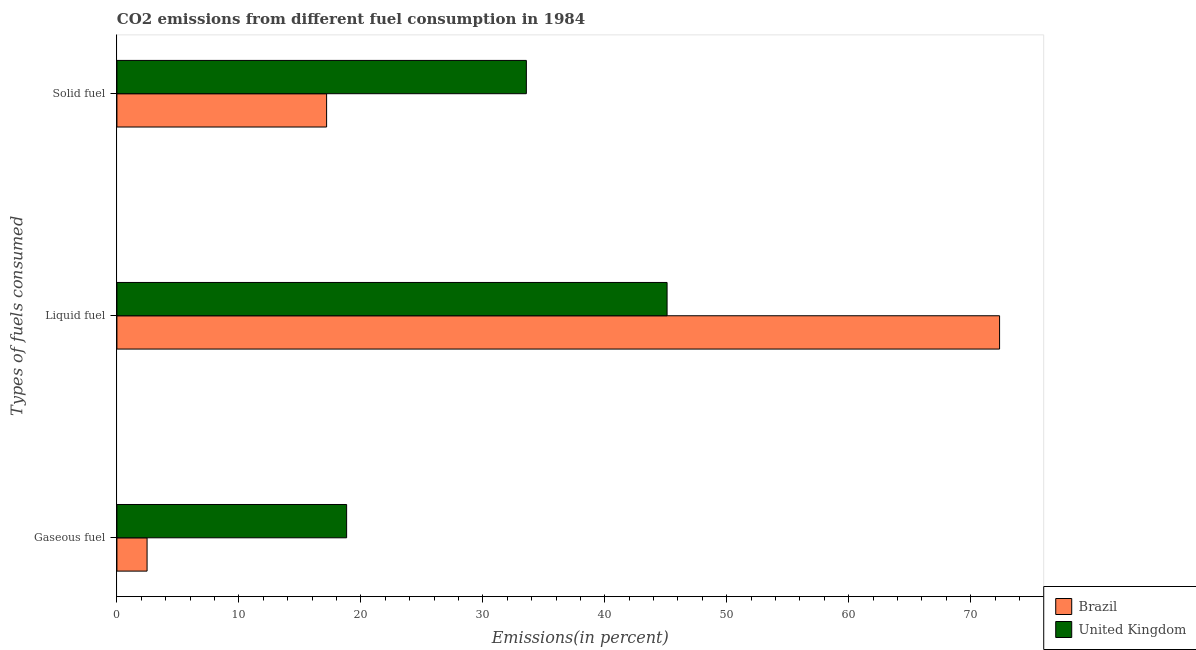How many different coloured bars are there?
Make the answer very short. 2. How many groups of bars are there?
Make the answer very short. 3. Are the number of bars per tick equal to the number of legend labels?
Offer a very short reply. Yes. How many bars are there on the 3rd tick from the top?
Your answer should be compact. 2. What is the label of the 1st group of bars from the top?
Provide a succinct answer. Solid fuel. What is the percentage of gaseous fuel emission in Brazil?
Make the answer very short. 2.47. Across all countries, what is the maximum percentage of liquid fuel emission?
Provide a succinct answer. 72.37. Across all countries, what is the minimum percentage of liquid fuel emission?
Keep it short and to the point. 45.11. What is the total percentage of gaseous fuel emission in the graph?
Your response must be concise. 21.31. What is the difference between the percentage of liquid fuel emission in Brazil and that in United Kingdom?
Make the answer very short. 27.26. What is the difference between the percentage of solid fuel emission in United Kingdom and the percentage of liquid fuel emission in Brazil?
Your answer should be very brief. -38.8. What is the average percentage of solid fuel emission per country?
Offer a terse response. 25.38. What is the difference between the percentage of gaseous fuel emission and percentage of solid fuel emission in United Kingdom?
Your response must be concise. -14.74. What is the ratio of the percentage of liquid fuel emission in Brazil to that in United Kingdom?
Your answer should be compact. 1.6. Is the percentage of gaseous fuel emission in United Kingdom less than that in Brazil?
Give a very brief answer. No. Is the difference between the percentage of liquid fuel emission in United Kingdom and Brazil greater than the difference between the percentage of gaseous fuel emission in United Kingdom and Brazil?
Your answer should be very brief. No. What is the difference between the highest and the second highest percentage of gaseous fuel emission?
Make the answer very short. 16.36. What is the difference between the highest and the lowest percentage of gaseous fuel emission?
Offer a very short reply. 16.36. Is the sum of the percentage of gaseous fuel emission in Brazil and United Kingdom greater than the maximum percentage of liquid fuel emission across all countries?
Make the answer very short. No. What does the 1st bar from the top in Solid fuel represents?
Keep it short and to the point. United Kingdom. Is it the case that in every country, the sum of the percentage of gaseous fuel emission and percentage of liquid fuel emission is greater than the percentage of solid fuel emission?
Your answer should be very brief. Yes. How many countries are there in the graph?
Your answer should be very brief. 2. Does the graph contain grids?
Ensure brevity in your answer.  No. Where does the legend appear in the graph?
Your answer should be compact. Bottom right. How many legend labels are there?
Provide a succinct answer. 2. What is the title of the graph?
Ensure brevity in your answer.  CO2 emissions from different fuel consumption in 1984. Does "Sao Tome and Principe" appear as one of the legend labels in the graph?
Your answer should be very brief. No. What is the label or title of the X-axis?
Ensure brevity in your answer.  Emissions(in percent). What is the label or title of the Y-axis?
Give a very brief answer. Types of fuels consumed. What is the Emissions(in percent) of Brazil in Gaseous fuel?
Your answer should be compact. 2.47. What is the Emissions(in percent) in United Kingdom in Gaseous fuel?
Provide a succinct answer. 18.83. What is the Emissions(in percent) of Brazil in Liquid fuel?
Make the answer very short. 72.37. What is the Emissions(in percent) in United Kingdom in Liquid fuel?
Your answer should be very brief. 45.11. What is the Emissions(in percent) in Brazil in Solid fuel?
Your answer should be very brief. 17.19. What is the Emissions(in percent) of United Kingdom in Solid fuel?
Ensure brevity in your answer.  33.57. Across all Types of fuels consumed, what is the maximum Emissions(in percent) in Brazil?
Offer a terse response. 72.37. Across all Types of fuels consumed, what is the maximum Emissions(in percent) of United Kingdom?
Give a very brief answer. 45.11. Across all Types of fuels consumed, what is the minimum Emissions(in percent) of Brazil?
Ensure brevity in your answer.  2.47. Across all Types of fuels consumed, what is the minimum Emissions(in percent) in United Kingdom?
Keep it short and to the point. 18.83. What is the total Emissions(in percent) of Brazil in the graph?
Keep it short and to the point. 92.03. What is the total Emissions(in percent) in United Kingdom in the graph?
Give a very brief answer. 97.51. What is the difference between the Emissions(in percent) in Brazil in Gaseous fuel and that in Liquid fuel?
Give a very brief answer. -69.9. What is the difference between the Emissions(in percent) of United Kingdom in Gaseous fuel and that in Liquid fuel?
Provide a short and direct response. -26.27. What is the difference between the Emissions(in percent) of Brazil in Gaseous fuel and that in Solid fuel?
Offer a terse response. -14.72. What is the difference between the Emissions(in percent) in United Kingdom in Gaseous fuel and that in Solid fuel?
Make the answer very short. -14.74. What is the difference between the Emissions(in percent) in Brazil in Liquid fuel and that in Solid fuel?
Your answer should be very brief. 55.18. What is the difference between the Emissions(in percent) of United Kingdom in Liquid fuel and that in Solid fuel?
Your answer should be very brief. 11.54. What is the difference between the Emissions(in percent) in Brazil in Gaseous fuel and the Emissions(in percent) in United Kingdom in Liquid fuel?
Offer a terse response. -42.64. What is the difference between the Emissions(in percent) in Brazil in Gaseous fuel and the Emissions(in percent) in United Kingdom in Solid fuel?
Offer a very short reply. -31.1. What is the difference between the Emissions(in percent) in Brazil in Liquid fuel and the Emissions(in percent) in United Kingdom in Solid fuel?
Keep it short and to the point. 38.8. What is the average Emissions(in percent) in Brazil per Types of fuels consumed?
Your response must be concise. 30.68. What is the average Emissions(in percent) in United Kingdom per Types of fuels consumed?
Give a very brief answer. 32.5. What is the difference between the Emissions(in percent) of Brazil and Emissions(in percent) of United Kingdom in Gaseous fuel?
Ensure brevity in your answer.  -16.36. What is the difference between the Emissions(in percent) in Brazil and Emissions(in percent) in United Kingdom in Liquid fuel?
Give a very brief answer. 27.26. What is the difference between the Emissions(in percent) in Brazil and Emissions(in percent) in United Kingdom in Solid fuel?
Ensure brevity in your answer.  -16.38. What is the ratio of the Emissions(in percent) in Brazil in Gaseous fuel to that in Liquid fuel?
Make the answer very short. 0.03. What is the ratio of the Emissions(in percent) of United Kingdom in Gaseous fuel to that in Liquid fuel?
Provide a short and direct response. 0.42. What is the ratio of the Emissions(in percent) in Brazil in Gaseous fuel to that in Solid fuel?
Offer a very short reply. 0.14. What is the ratio of the Emissions(in percent) in United Kingdom in Gaseous fuel to that in Solid fuel?
Provide a succinct answer. 0.56. What is the ratio of the Emissions(in percent) of Brazil in Liquid fuel to that in Solid fuel?
Keep it short and to the point. 4.21. What is the ratio of the Emissions(in percent) of United Kingdom in Liquid fuel to that in Solid fuel?
Your answer should be compact. 1.34. What is the difference between the highest and the second highest Emissions(in percent) of Brazil?
Provide a succinct answer. 55.18. What is the difference between the highest and the second highest Emissions(in percent) of United Kingdom?
Keep it short and to the point. 11.54. What is the difference between the highest and the lowest Emissions(in percent) of Brazil?
Your answer should be very brief. 69.9. What is the difference between the highest and the lowest Emissions(in percent) in United Kingdom?
Your response must be concise. 26.27. 